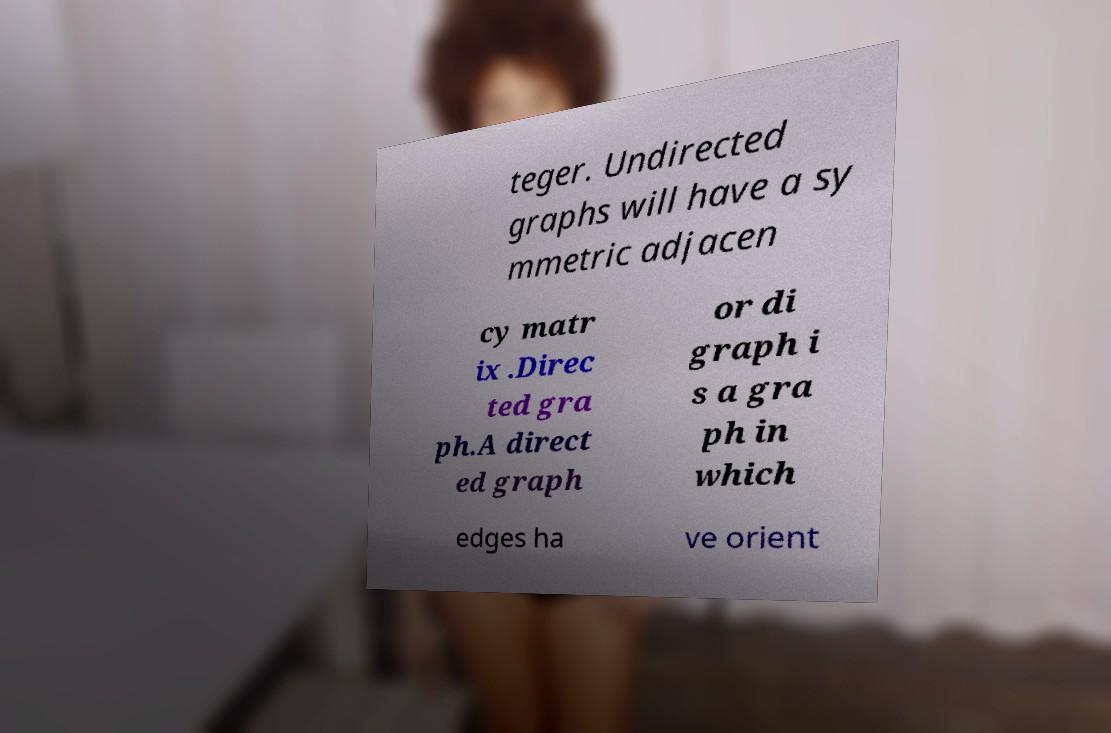Can you accurately transcribe the text from the provided image for me? teger. Undirected graphs will have a sy mmetric adjacen cy matr ix .Direc ted gra ph.A direct ed graph or di graph i s a gra ph in which edges ha ve orient 